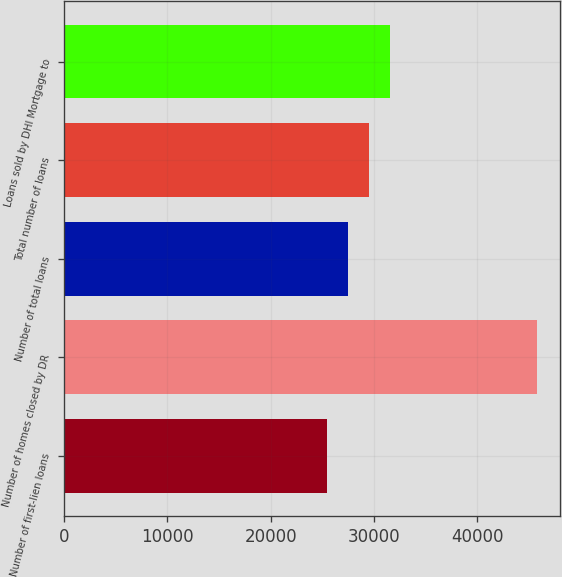<chart> <loc_0><loc_0><loc_500><loc_500><bar_chart><fcel>Number of first-lien loans<fcel>Number of homes closed by DR<fcel>Number of total loans<fcel>Total number of loans<fcel>Loans sold by DHI Mortgage to<nl><fcel>25488<fcel>45751<fcel>27514.3<fcel>29540.6<fcel>31566.9<nl></chart> 